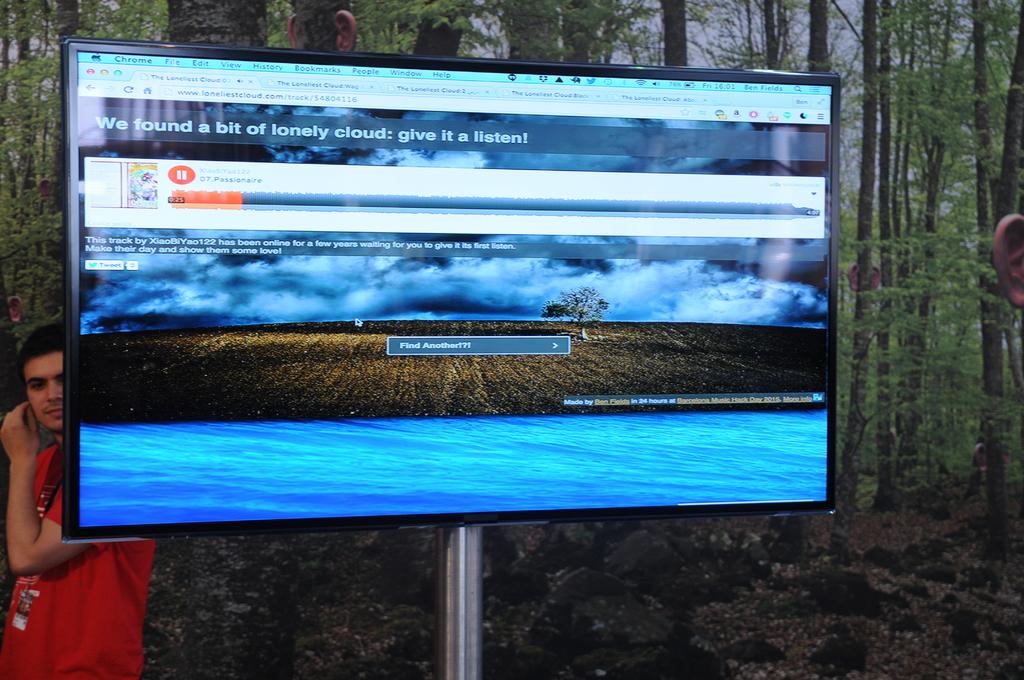What does it say it found?
Provide a short and direct response. A bit of lonely cloud. What browser is this computer using?
Keep it short and to the point. Chrome. 